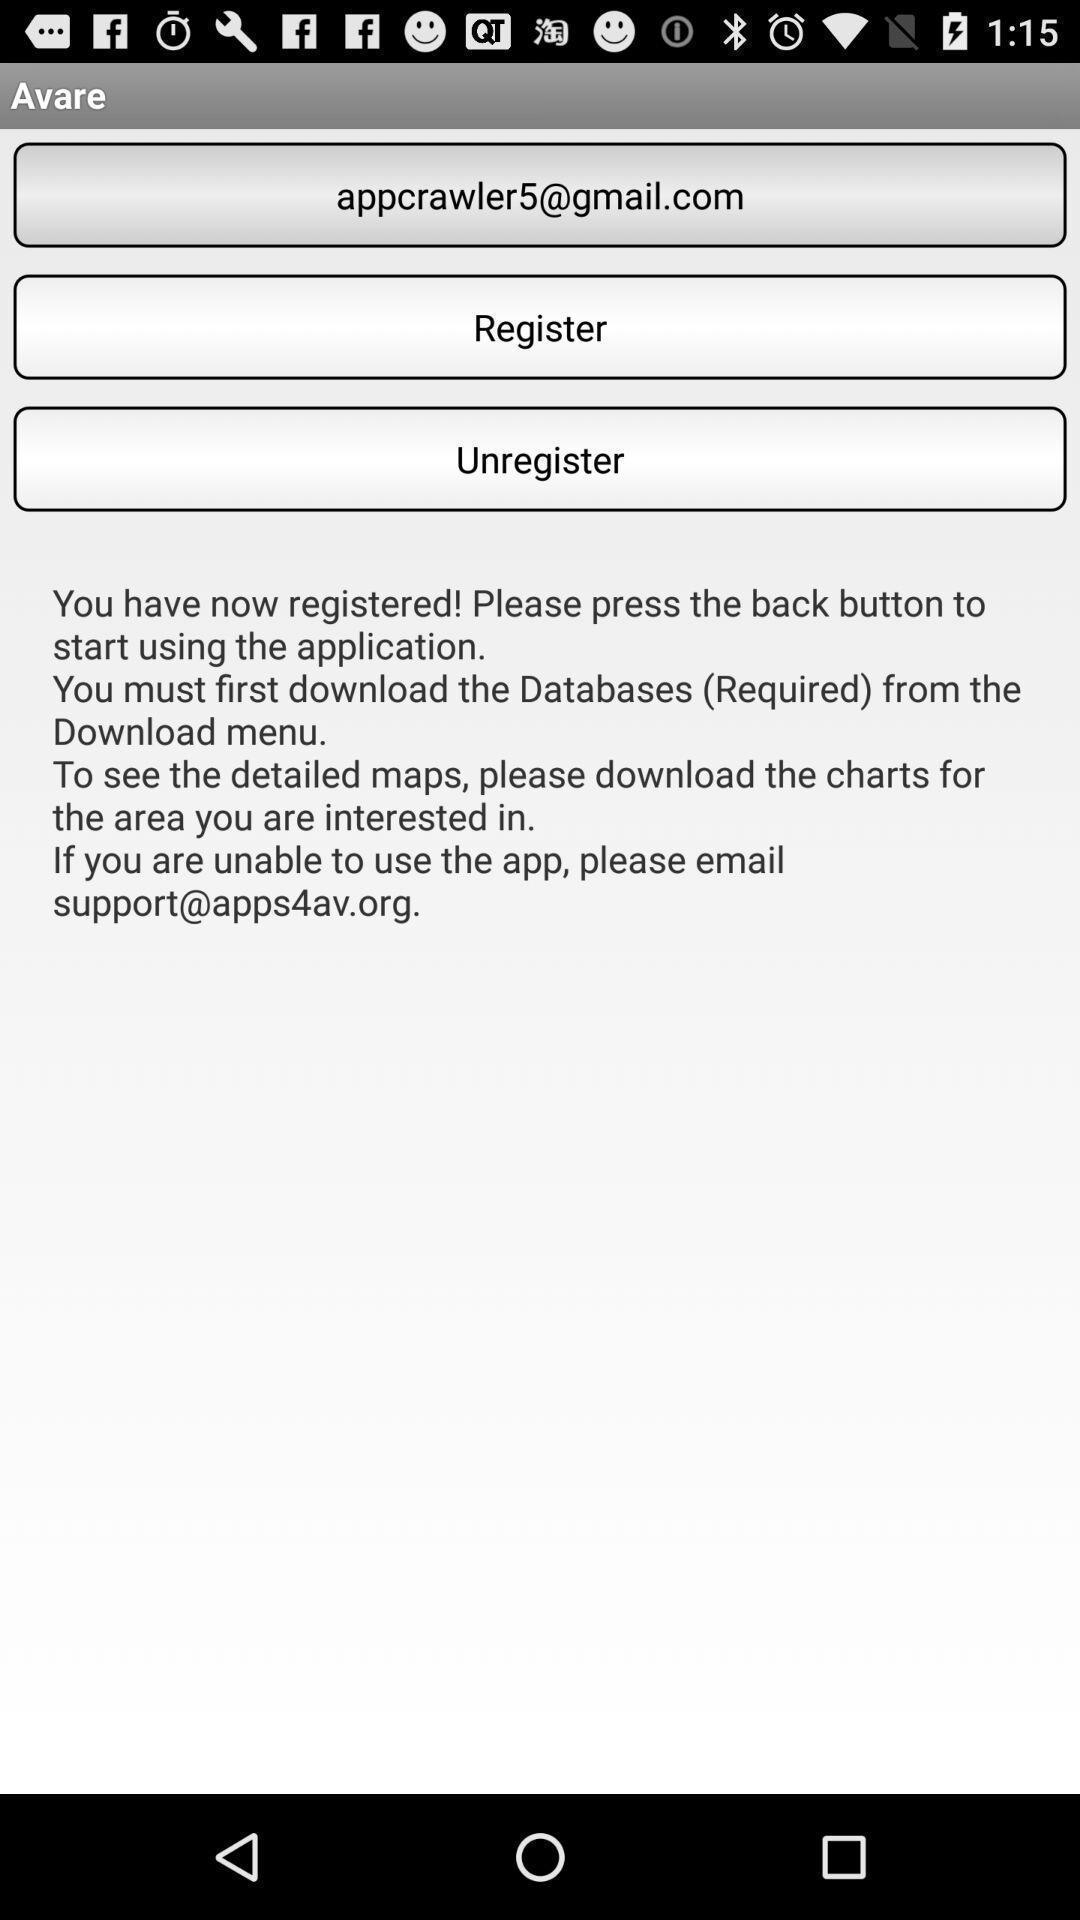Summarize the main components in this picture. Sign in page of a map app. 